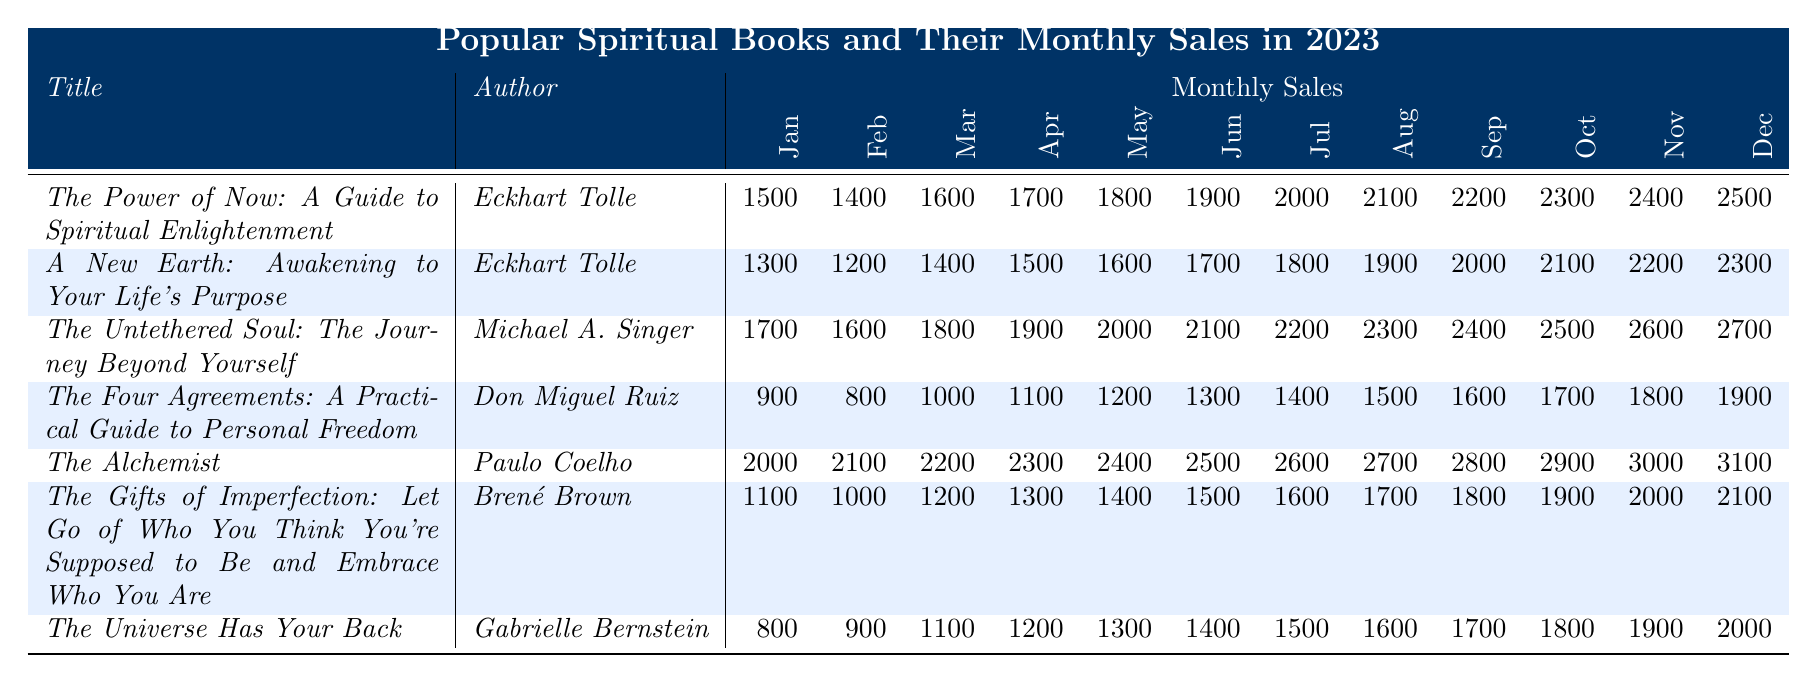What is the total sales for "The Power of Now" in 2023? To find the total sales, add up the monthly sales: 1500 + 1400 + 1600 + 1700 + 1800 + 1900 + 2000 + 2100 + 2200 + 2300 + 2400 + 2500 = 25000
Answer: 25000 Which book had the highest sales in December 2023? In December, the monthly sales for each book are as follows: "The Power of Now" (2500), "A New Earth" (2300), "The Untethered Soul" (2700), "The Four Agreements" (1900), "The Alchemist" (3100), "The Gifts of Imperfection" (2100), "The Universe Has Your Back" (2000). The highest is 3100 for "The Alchemist."
Answer: The Alchemist What is the average monthly sales for "The Untethered Soul"? The monthly sales for "The Untethered Soul" are: 1700, 1600, 1800, 1900, 2000, 2100, 2200, 2300, 2400, 2500, 2600, 2700. There are 12 values, summing to 28200. The average is 28200/12 = 2350.
Answer: 2350 Did "The Universe Has Your Back" have more total sales than "The Four Agreements"? Sum the total sales for each: "The Universe Has Your Back" = 800 + 900 + 1100 + 1200 + 1300 + 1400 + 1500 + 1600 + 1700 + 1800 + 1900 + 2000 = 19000. "The Four Agreements" = 900 + 800 + 1000 + 1100 + 1200 + 1300 + 1400 + 1500 + 1600 + 1700 + 1800 + 1900 = 19000. They are equal.
Answer: No What is the increase in sales from January to December for "The Alchemist"? The sales figures are 2000 (January) and 3100 (December). The increase is 3100 - 2000 = 1100.
Answer: 1100 Which author has the highest cumulative sales for their books throughout 2023? "Eckhart Tolle" has two books: "The Power of Now" (25000) and "A New Earth" (23000), summing to 48000. "Michael A. Singer" has 32400, "Don Miguel Ruiz" has 20700, "Paulo Coelho" has 34800, "Brené Brown" has 21000, and "Gabrielle Bernstein" has 19000. The highest is 48000 for Eckhart Tolle.
Answer: Eckhart Tolle How much did "The Gifts of Imperfection" sell in June compared to "The Untethered Soul"? "The Gifts of Imperfection" sold 1500 in June while "The Untethered Soul" sold 2100. The comparison shows a difference of 2100 - 1500 = 600, meaning "The Untethered Soul" sold 600 more in June.
Answer: 600 What was the median monthly sales of "The Four Agreements"? The monthly sales for "The Four Agreements" are 900, 800, 1000, 1100, 1200, 1300, 1400, 1500, 1600, 1700, 1800, 1900, which arranged in order give: 800, 900, 1000, 1100, 1200, 1300, 1400, 1500, 1600, 1700, 1800, 1900. The median is the average of the 6th and 7th numbers: (1300 + 1400) / 2 = 1350.
Answer: 1350 What trend can be observed in the sales of "The Alchemist" over the year? The sales of "The Alchemist" show a consistent increase every month, starting from 2000 in January to 3100 in December. This indicates a positive upward trend in sales throughout the year.
Answer: Consistent increase 